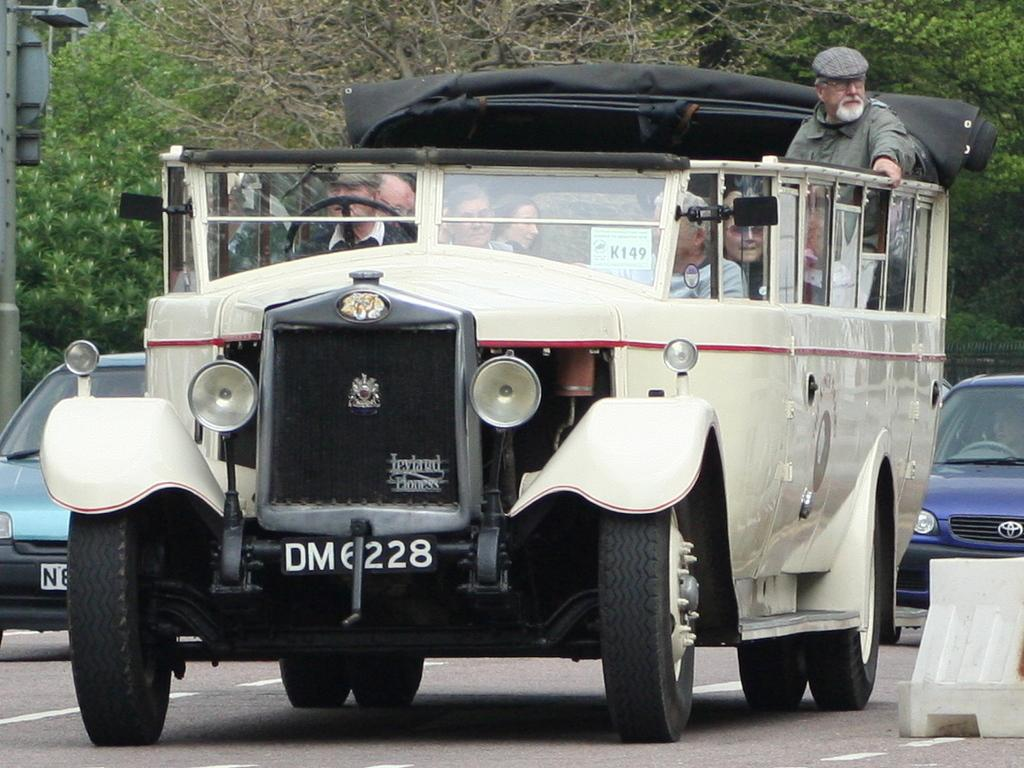What are the people in the image doing? The people in the image are sitting in a vehicle. What can be seen in the background of the image? Cars and trees are visible in the background. Can you describe the object on the right side of the road? There is a white color object on the right side of the road. How many grapes are hanging from the trees in the image? There are no grapes visible in the image; only trees are present in the background. 